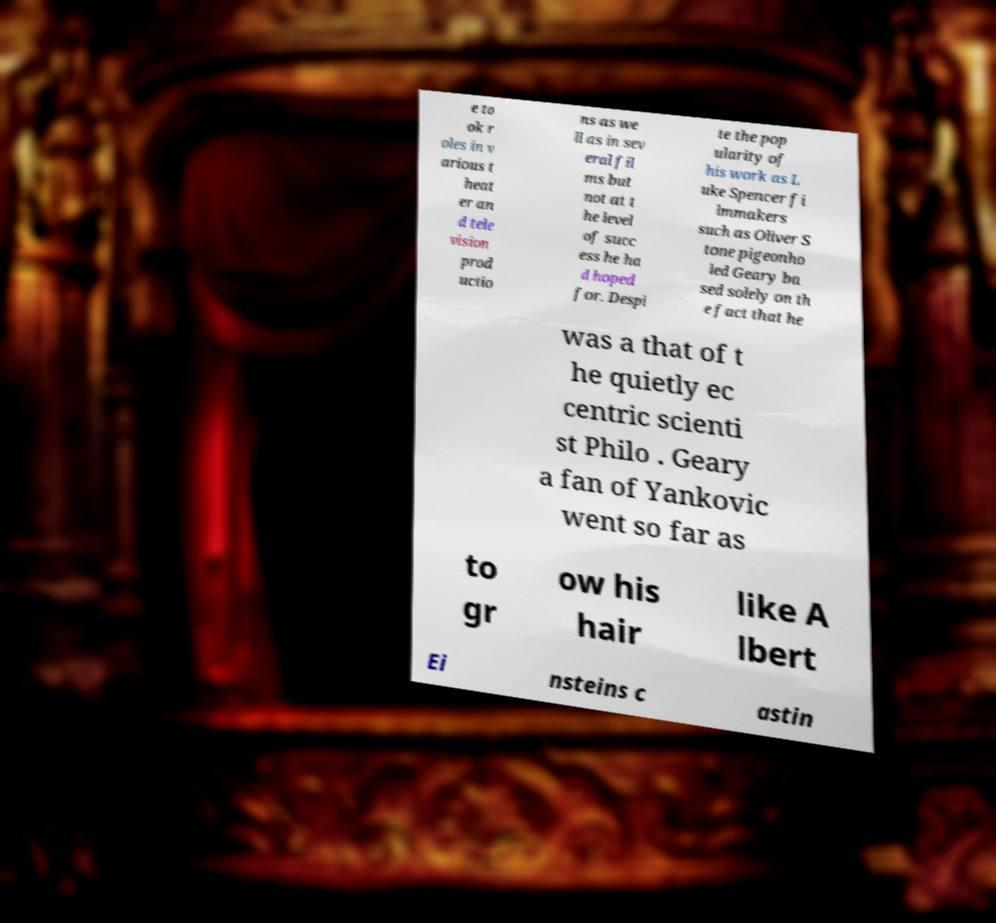I need the written content from this picture converted into text. Can you do that? e to ok r oles in v arious t heat er an d tele vision prod uctio ns as we ll as in sev eral fil ms but not at t he level of succ ess he ha d hoped for. Despi te the pop ularity of his work as L uke Spencer fi lmmakers such as Oliver S tone pigeonho led Geary ba sed solely on th e fact that he was a that of t he quietly ec centric scienti st Philo . Geary a fan of Yankovic went so far as to gr ow his hair like A lbert Ei nsteins c astin 